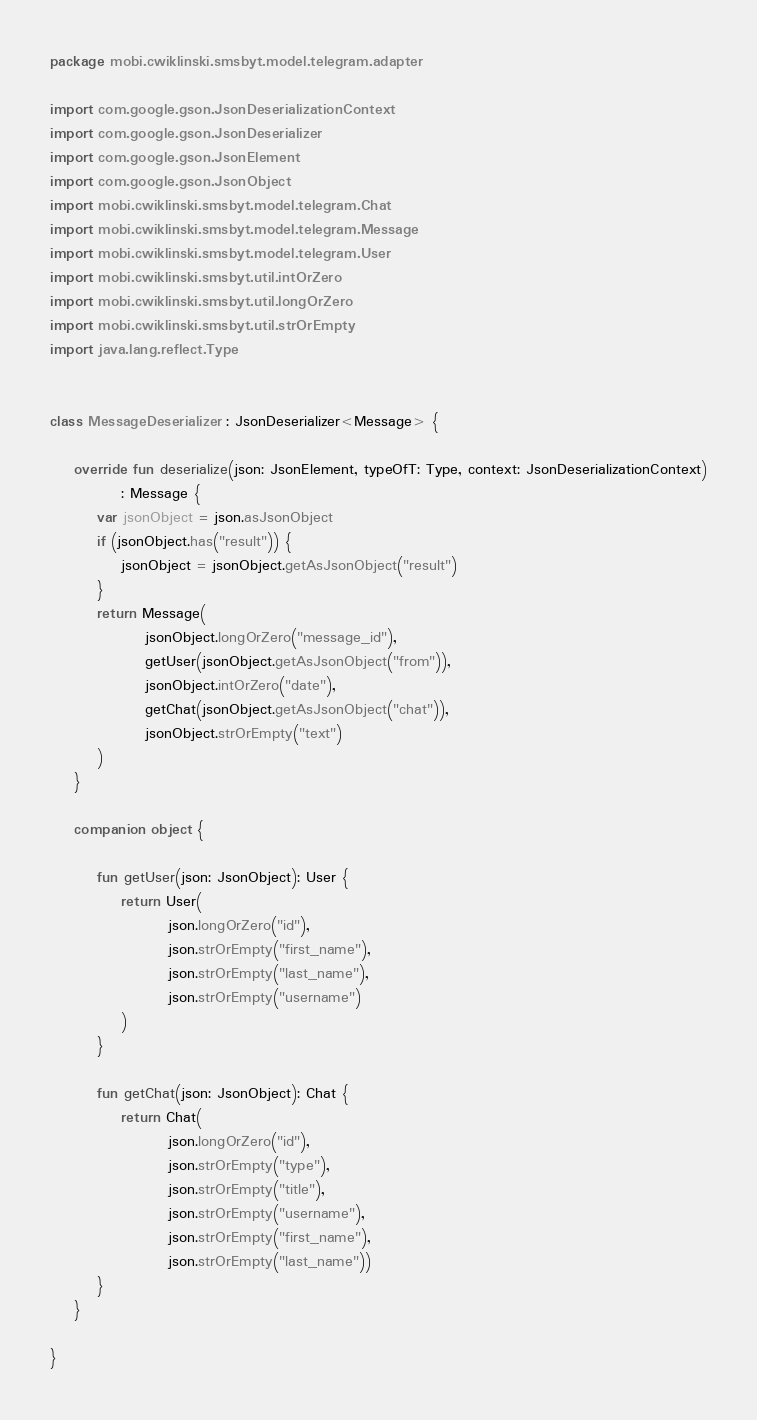Convert code to text. <code><loc_0><loc_0><loc_500><loc_500><_Kotlin_>package mobi.cwiklinski.smsbyt.model.telegram.adapter

import com.google.gson.JsonDeserializationContext
import com.google.gson.JsonDeserializer
import com.google.gson.JsonElement
import com.google.gson.JsonObject
import mobi.cwiklinski.smsbyt.model.telegram.Chat
import mobi.cwiklinski.smsbyt.model.telegram.Message
import mobi.cwiklinski.smsbyt.model.telegram.User
import mobi.cwiklinski.smsbyt.util.intOrZero
import mobi.cwiklinski.smsbyt.util.longOrZero
import mobi.cwiklinski.smsbyt.util.strOrEmpty
import java.lang.reflect.Type


class MessageDeserializer : JsonDeserializer<Message> {

    override fun deserialize(json: JsonElement, typeOfT: Type, context: JsonDeserializationContext)
            : Message {
        var jsonObject = json.asJsonObject
        if (jsonObject.has("result")) {
            jsonObject = jsonObject.getAsJsonObject("result")
        }
        return Message(
                jsonObject.longOrZero("message_id"),
                getUser(jsonObject.getAsJsonObject("from")),
                jsonObject.intOrZero("date"),
                getChat(jsonObject.getAsJsonObject("chat")),
                jsonObject.strOrEmpty("text")
        )
    }

    companion object {

        fun getUser(json: JsonObject): User {
            return User(
                    json.longOrZero("id"),
                    json.strOrEmpty("first_name"),
                    json.strOrEmpty("last_name"),
                    json.strOrEmpty("username")
            )
        }

        fun getChat(json: JsonObject): Chat {
            return Chat(
                    json.longOrZero("id"),
                    json.strOrEmpty("type"),
                    json.strOrEmpty("title"),
                    json.strOrEmpty("username"),
                    json.strOrEmpty("first_name"),
                    json.strOrEmpty("last_name"))
        }
    }

}</code> 